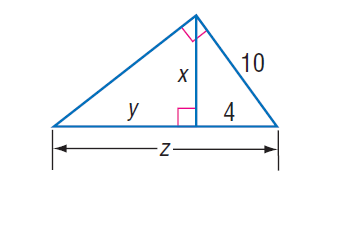Question: Find z.
Choices:
A. 5
B. 16
C. 21
D. 25
Answer with the letter. Answer: D Question: Find x.
Choices:
A. \sqrt { 7 }
B. \sqrt { 21 }
C. 2 \sqrt { 21 }
D. 21
Answer with the letter. Answer: C 